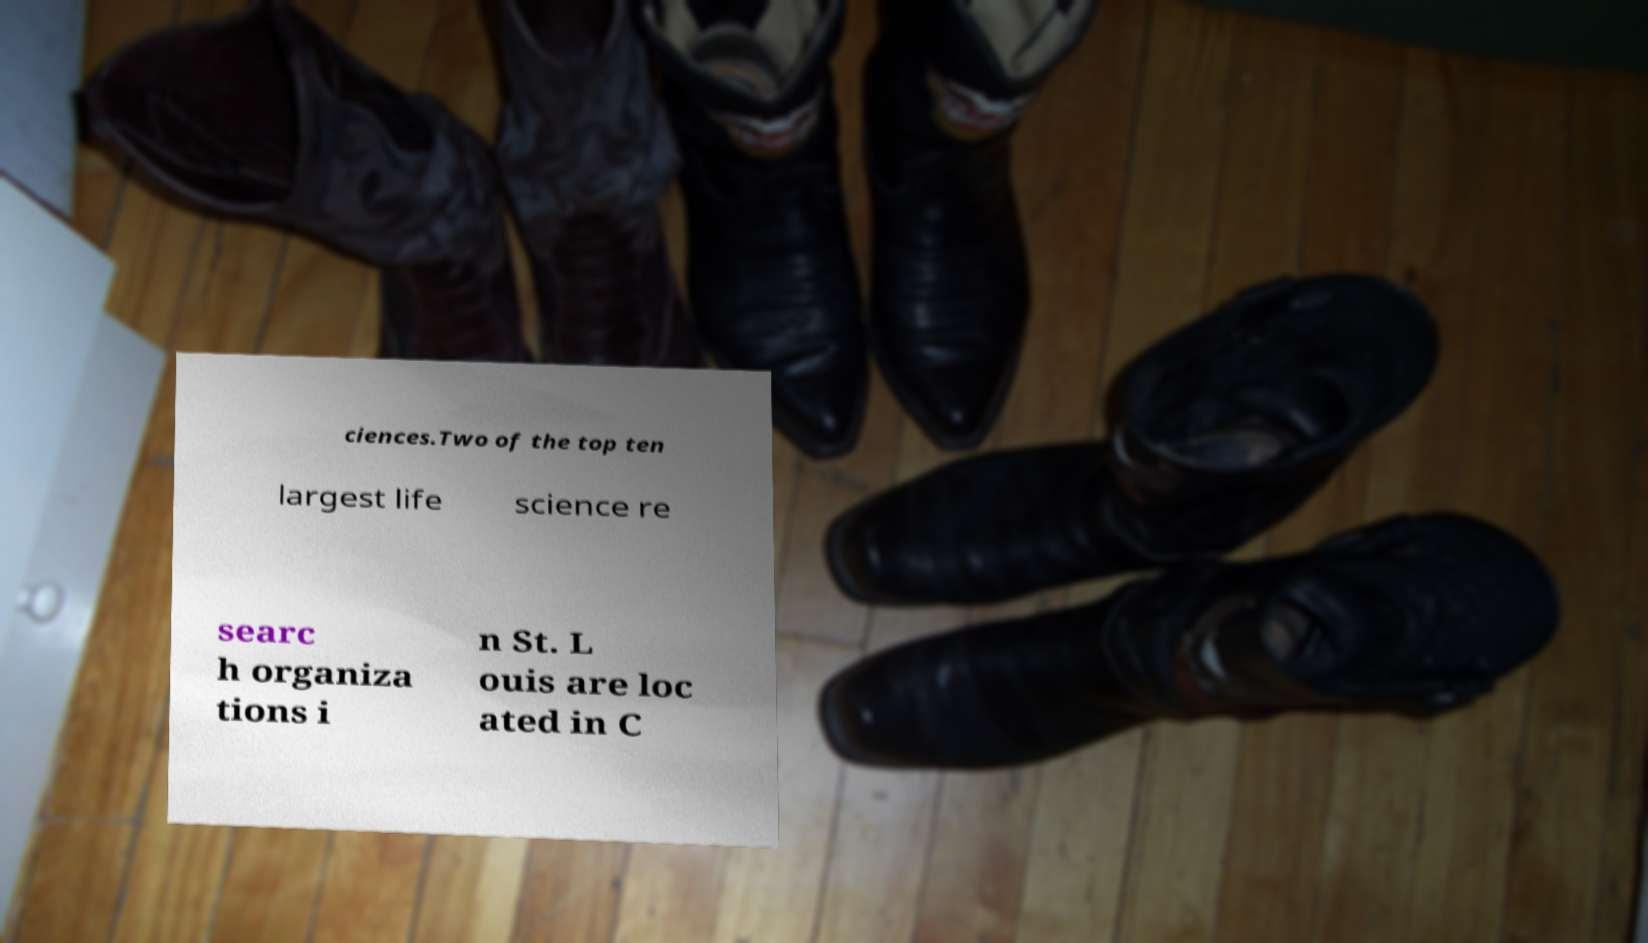I need the written content from this picture converted into text. Can you do that? ciences.Two of the top ten largest life science re searc h organiza tions i n St. L ouis are loc ated in C 